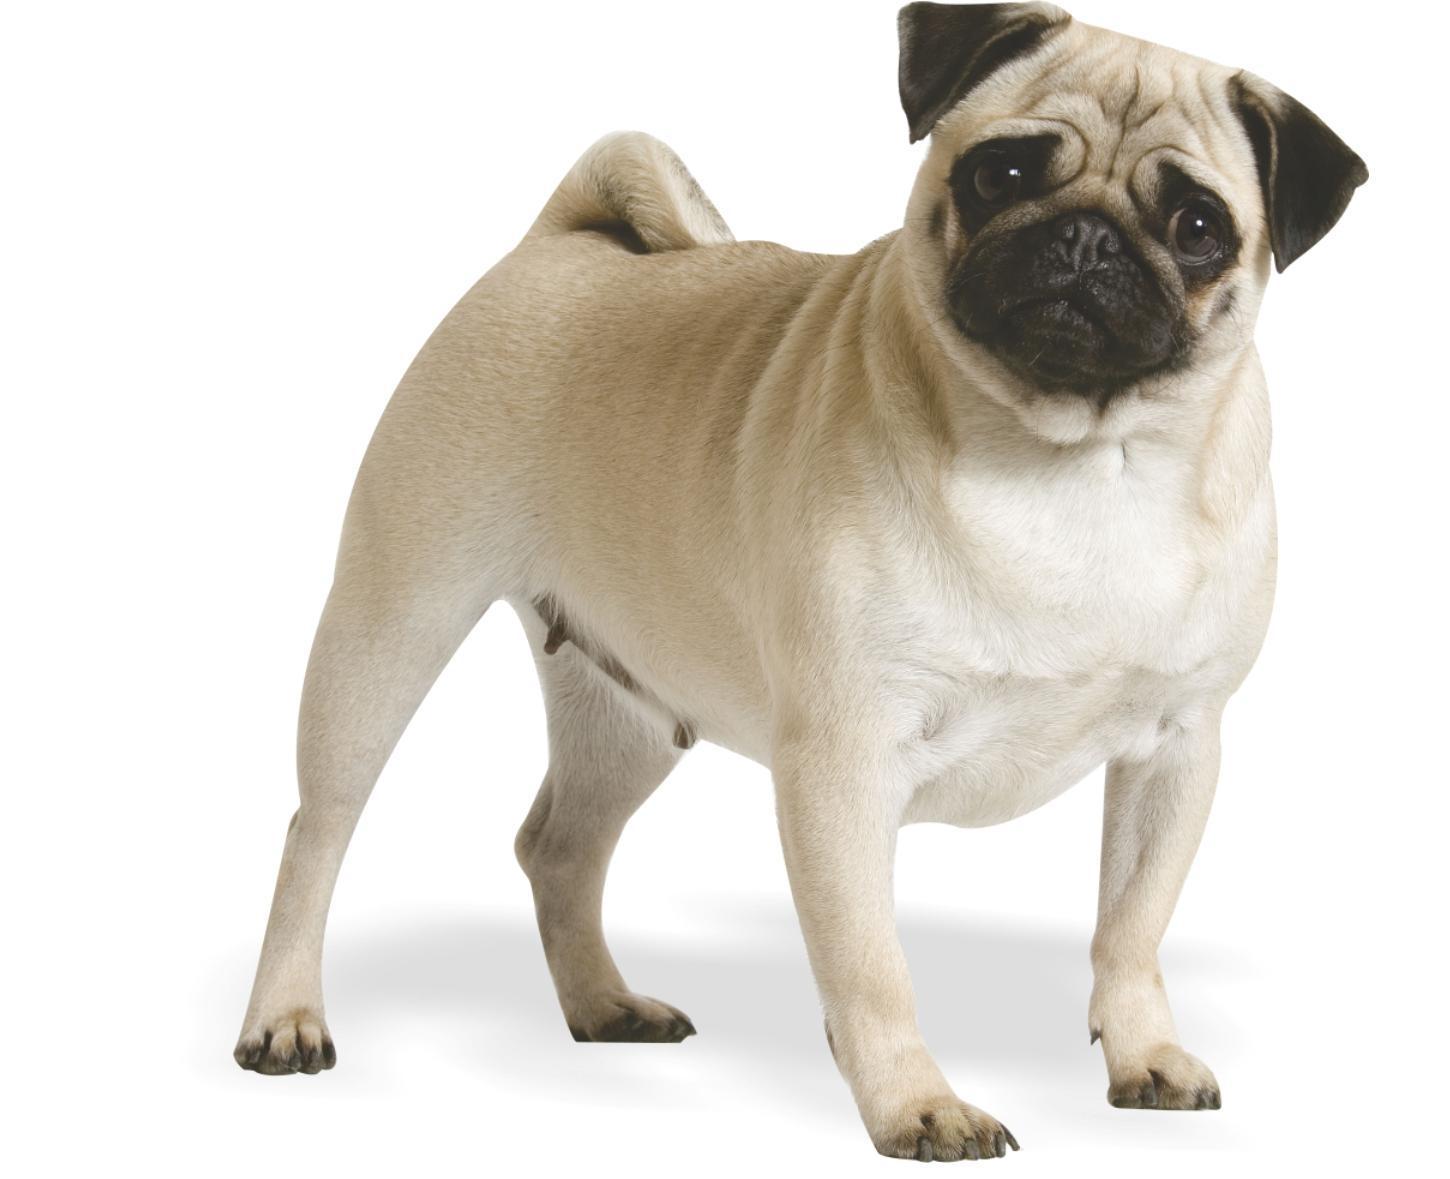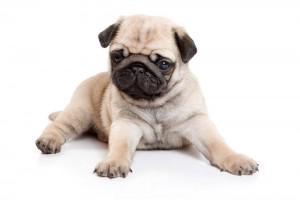The first image is the image on the left, the second image is the image on the right. For the images shown, is this caption "There is a single dog on the left image sitting with his front legs stretched up." true? Answer yes or no. No. 